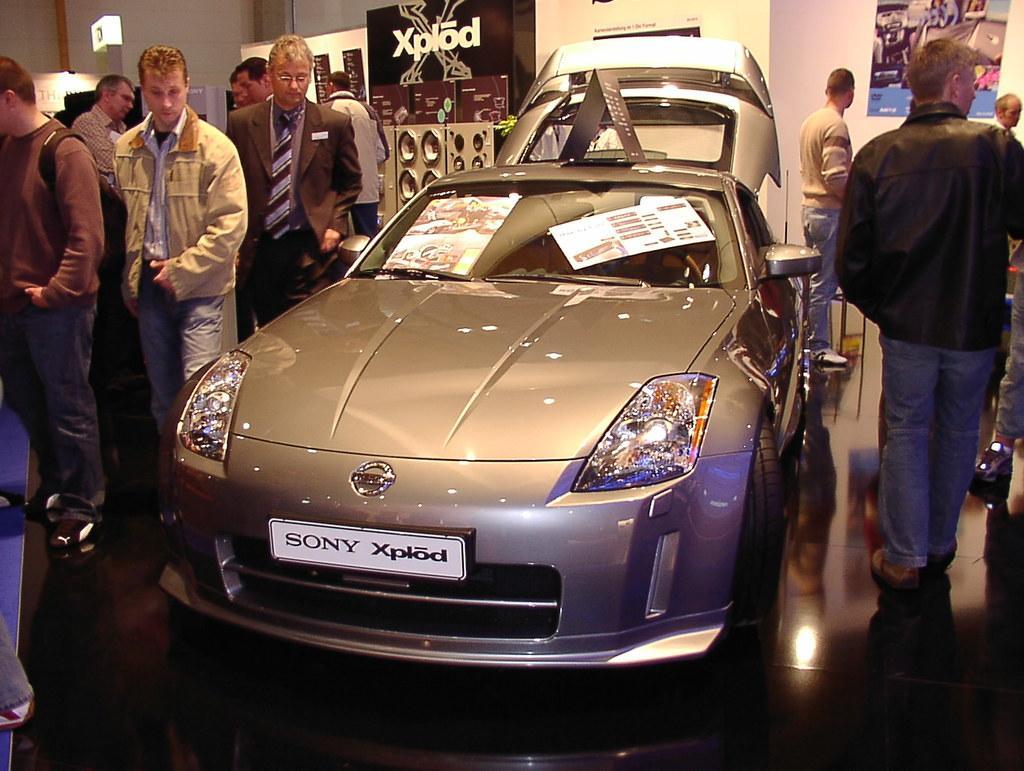Could you give a brief overview of what you see in this image? In this picture we can see a car and aside to this car we can see some persons standing and in the background we can see wall, banners. 